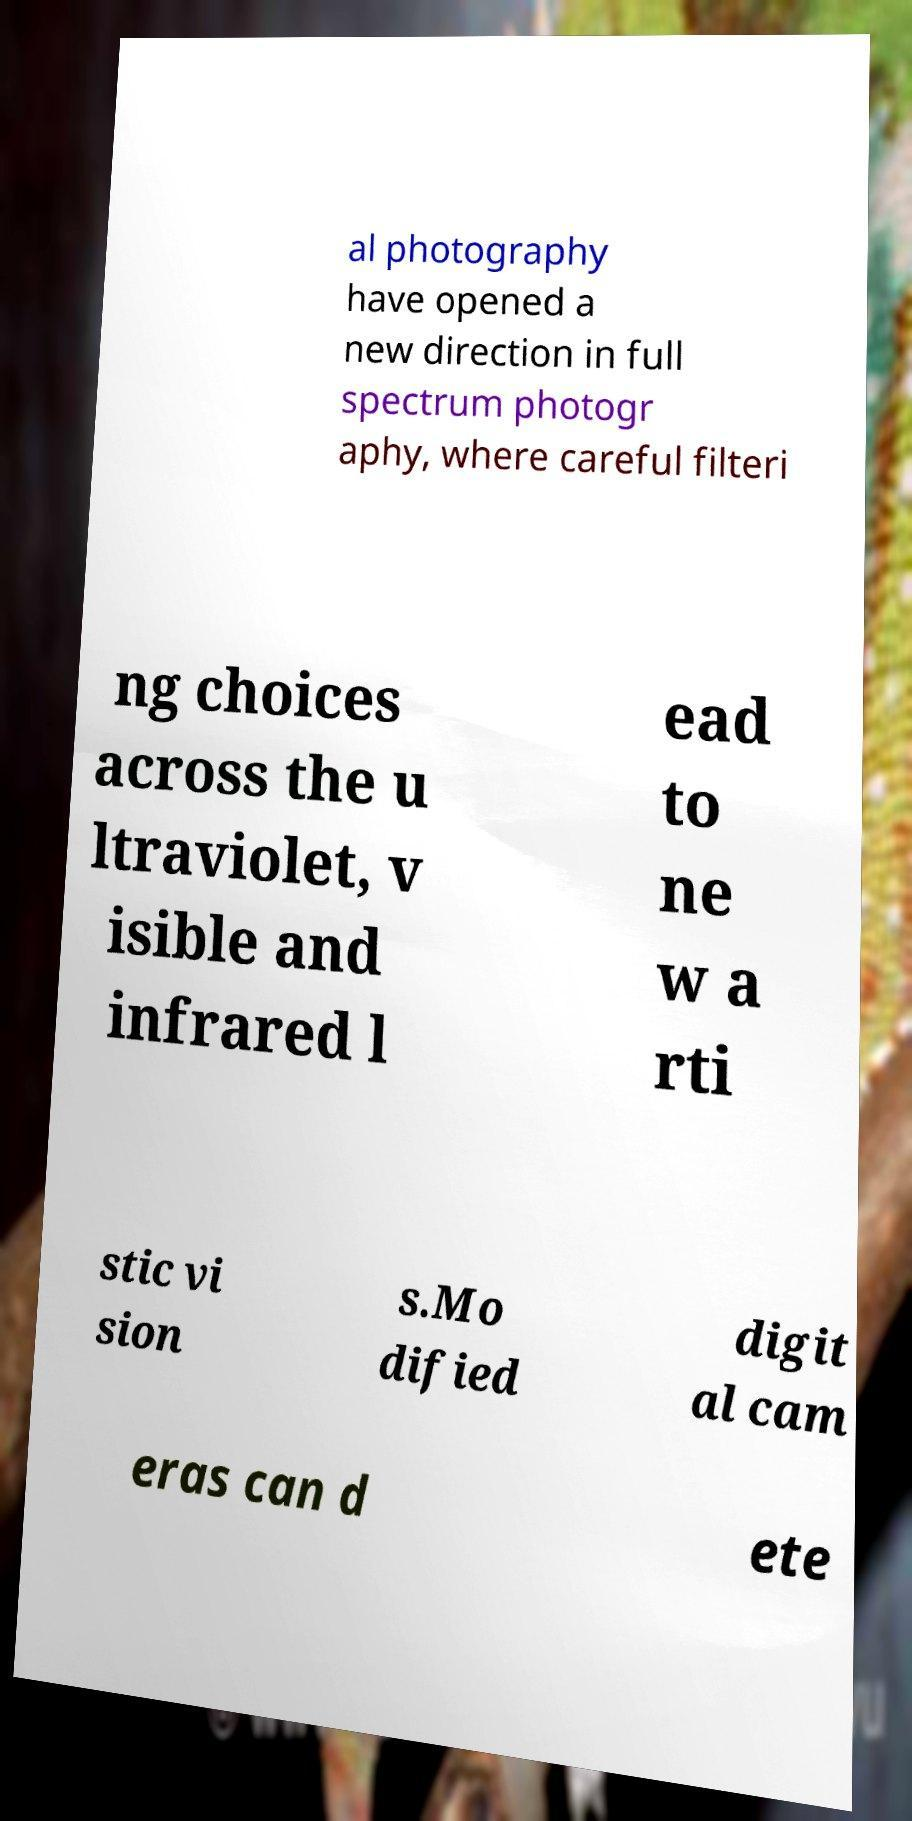I need the written content from this picture converted into text. Can you do that? al photography have opened a new direction in full spectrum photogr aphy, where careful filteri ng choices across the u ltraviolet, v isible and infrared l ead to ne w a rti stic vi sion s.Mo dified digit al cam eras can d ete 